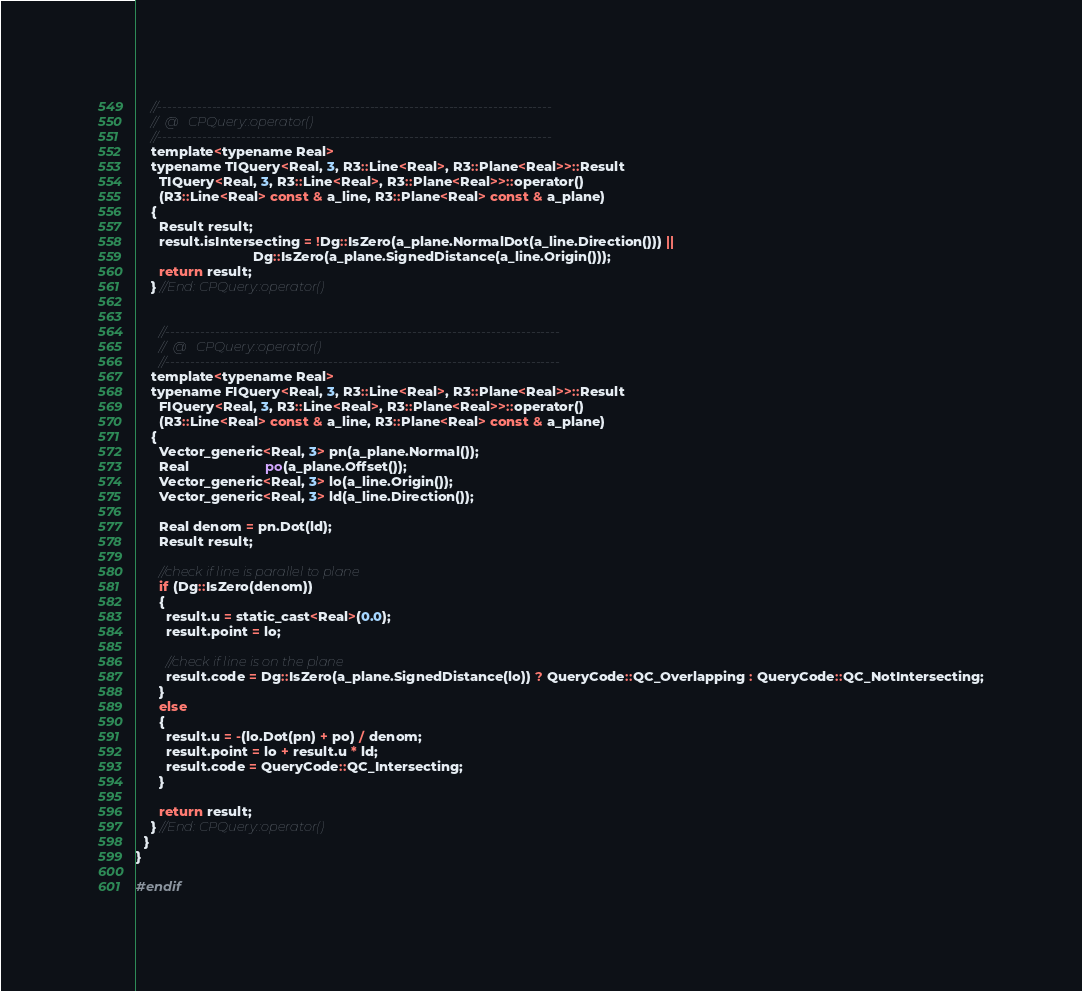Convert code to text. <code><loc_0><loc_0><loc_500><loc_500><_C_>

    //--------------------------------------------------------------------------------
    //	@	CPQuery::operator()
    //--------------------------------------------------------------------------------
    template<typename Real>
    typename TIQuery<Real, 3, R3::Line<Real>, R3::Plane<Real>>::Result
      TIQuery<Real, 3, R3::Line<Real>, R3::Plane<Real>>::operator()
      (R3::Line<Real> const & a_line, R3::Plane<Real> const & a_plane)
    {
      Result result;
      result.isIntersecting = !Dg::IsZero(a_plane.NormalDot(a_line.Direction())) ||
                               Dg::IsZero(a_plane.SignedDistance(a_line.Origin()));
      return result;
    } //End: CPQuery::operator()


      //--------------------------------------------------------------------------------
      //	@	CPQuery::operator()
      //--------------------------------------------------------------------------------
    template<typename Real>
    typename FIQuery<Real, 3, R3::Line<Real>, R3::Plane<Real>>::Result
      FIQuery<Real, 3, R3::Line<Real>, R3::Plane<Real>>::operator()
      (R3::Line<Real> const & a_line, R3::Plane<Real> const & a_plane)
    {
      Vector_generic<Real, 3> pn(a_plane.Normal());
      Real                    po(a_plane.Offset());
      Vector_generic<Real, 3> lo(a_line.Origin());
      Vector_generic<Real, 3> ld(a_line.Direction());

      Real denom = pn.Dot(ld);
      Result result;

      //check if line is parallel to plane
      if (Dg::IsZero(denom))
      {
        result.u = static_cast<Real>(0.0);
        result.point = lo;

        //check if line is on the plane
        result.code = Dg::IsZero(a_plane.SignedDistance(lo)) ? QueryCode::QC_Overlapping : QueryCode::QC_NotIntersecting;
      }
      else
      {
        result.u = -(lo.Dot(pn) + po) / denom;
        result.point = lo + result.u * ld;
        result.code = QueryCode::QC_Intersecting;
      }

      return result;
    } //End: CPQuery::operator()
  }
}

#endif</code> 